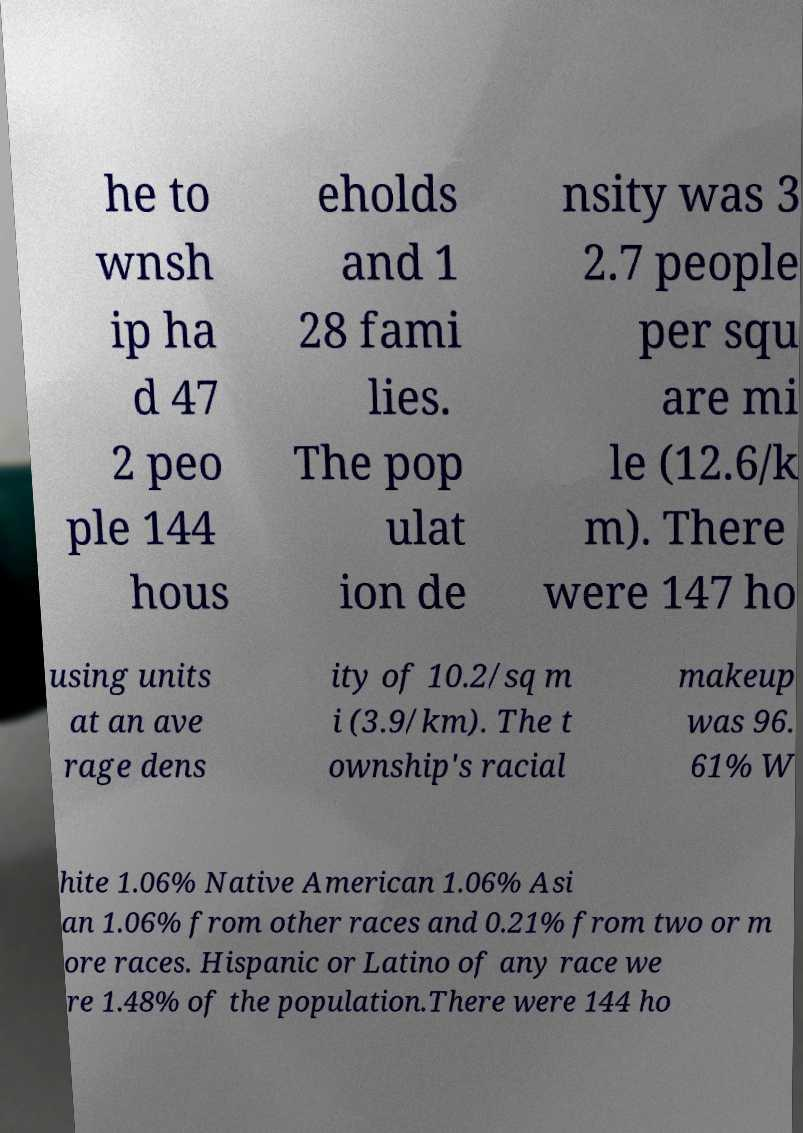I need the written content from this picture converted into text. Can you do that? he to wnsh ip ha d 47 2 peo ple 144 hous eholds and 1 28 fami lies. The pop ulat ion de nsity was 3 2.7 people per squ are mi le (12.6/k m). There were 147 ho using units at an ave rage dens ity of 10.2/sq m i (3.9/km). The t ownship's racial makeup was 96. 61% W hite 1.06% Native American 1.06% Asi an 1.06% from other races and 0.21% from two or m ore races. Hispanic or Latino of any race we re 1.48% of the population.There were 144 ho 